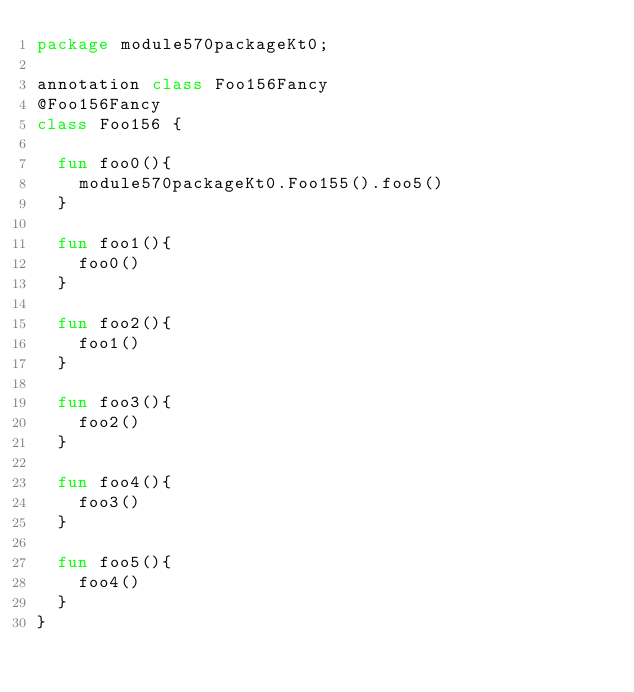<code> <loc_0><loc_0><loc_500><loc_500><_Kotlin_>package module570packageKt0;

annotation class Foo156Fancy
@Foo156Fancy
class Foo156 {

  fun foo0(){
    module570packageKt0.Foo155().foo5()
  }

  fun foo1(){
    foo0()
  }

  fun foo2(){
    foo1()
  }

  fun foo3(){
    foo2()
  }

  fun foo4(){
    foo3()
  }

  fun foo5(){
    foo4()
  }
}</code> 